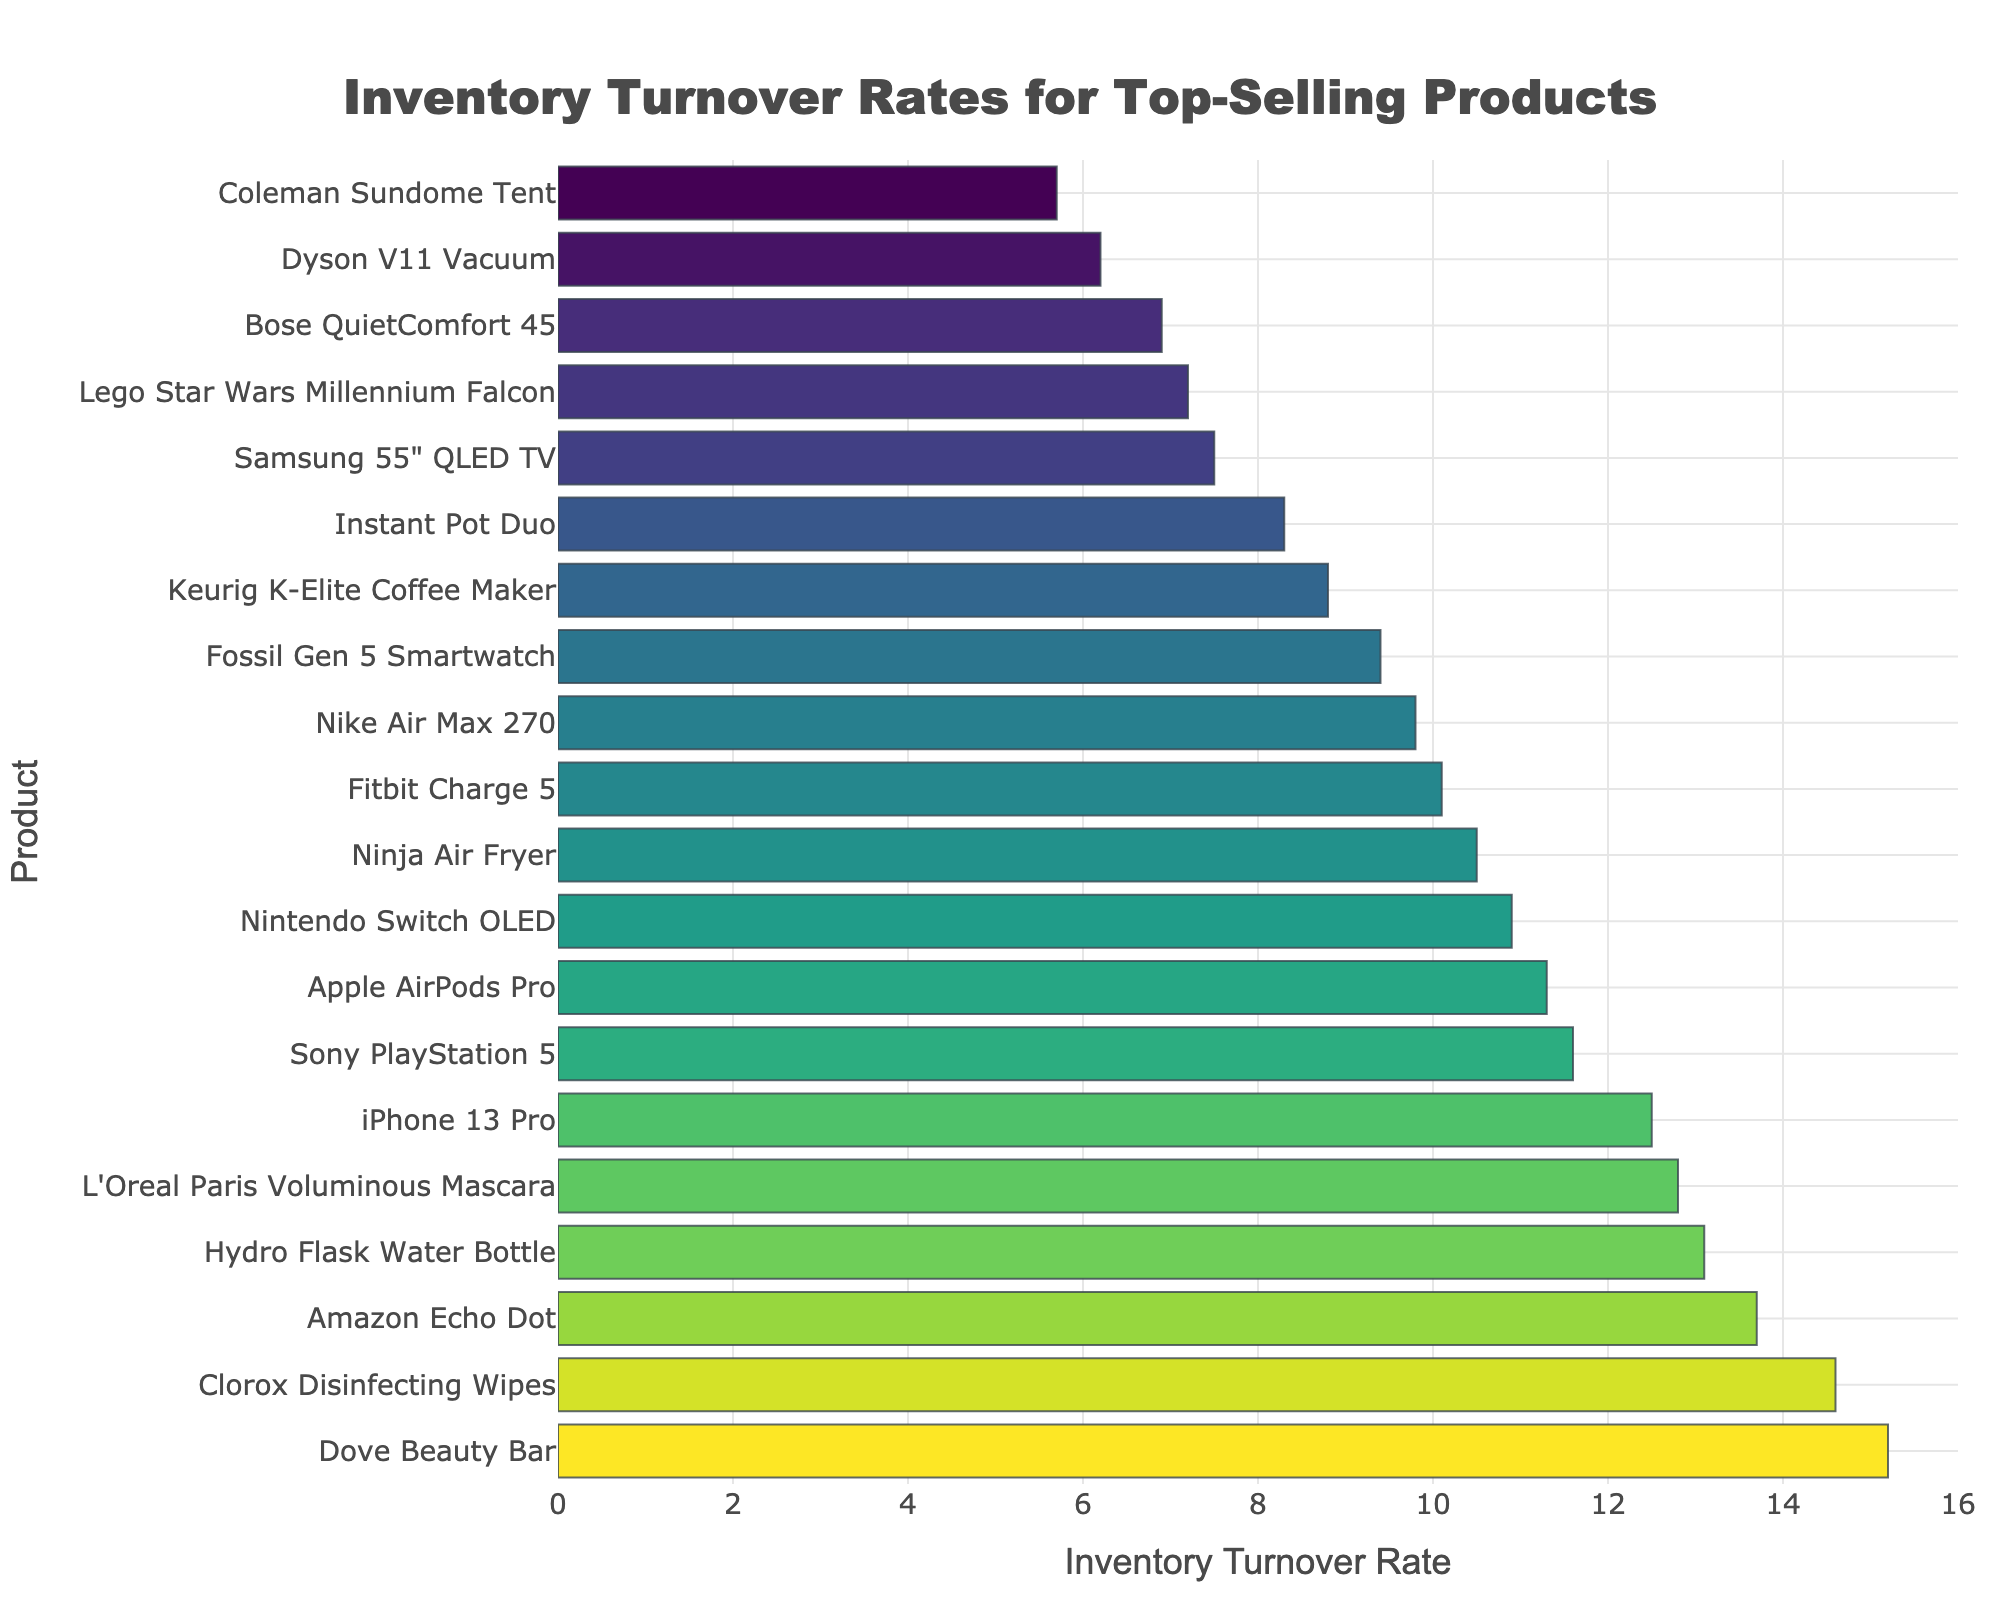What product has the highest inventory turnover rate? Look at the bar chart and identify the product with the longest bar and the highest value on the x-axis.
Answer: Dove Beauty Bar Which product has a lower inventory turnover rate, Bose QuietComfort 45 or Samsung 55" QLED TV? Compare the lengths of the bars corresponding to Bose QuietComfort 45 and Samsung 55" QLED TV to see which one is shorter.
Answer: Bose QuietComfort 45 What is the difference in inventory turnover rate between Amazon Echo Dot and iPhone 13 Pro? Subtract the inventory turnover rate of the iPhone 13 Pro from that of the Amazon Echo Dot (13.7 - 12.5).
Answer: 1.2 What is the average inventory turnover rate for the top three products? Sum the turnover rates of the top three products (Dove Beauty Bar, Clorox Disinfecting Wipes, and Amazon Echo Dot) and then divide by three ((15.2 + 14.6 + 13.7) / 3).
Answer: 14.5 How many products have an inventory turnover rate greater than 10? Count the number of bars with turnover rates greater than 10.
Answer: 10 Which has a higher turnover rate, Fitbit Charge 5 or Nintendo Switch OLED? Compare the lengths of the bars for Fitbit Charge 5 and Nintendo Switch OLED to see which one is longer.
Answer: Nintendo Switch OLED What is the total inventory turnover rate for all products listed? Sum all the inventory turnover rates from the data provided (12.5 + 9.8 + 8.3 + 7.2 + 11.6 + 10.1 + 13.7 + 15.2 + 6.9 + 8.8 + 10.9 + 14.6 + 11.3 + 7.5 + 6.2 + 12.8 + 5.7 + 9.4 + 10.5 + 13.1).
Answer: 199.1 Which product has the closest inventory turnover rate to 10.0? Find the product with the inventory turnover rate value closest to 10 in the data provided.
Answer: Fitbit Charge 5 